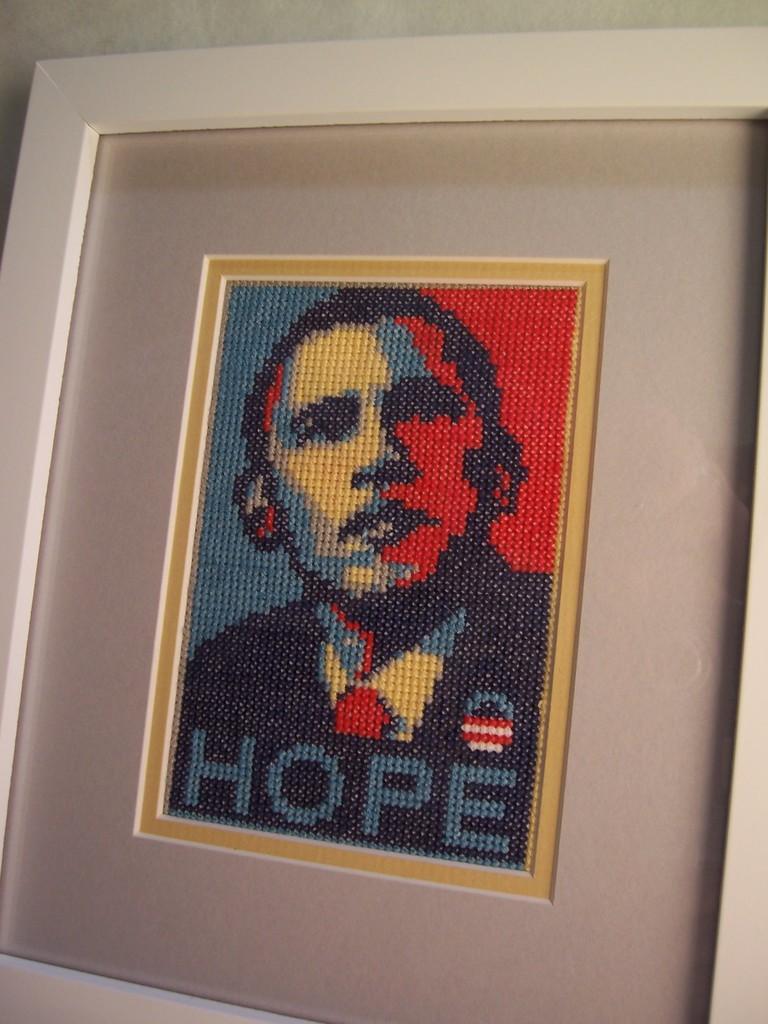Could you give a brief overview of what you see in this image? In this image there is a photo frame. In the photo frame there is an art. 